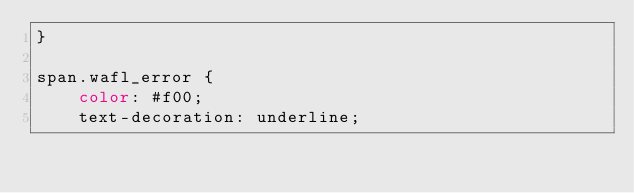<code> <loc_0><loc_0><loc_500><loc_500><_CSS_>}

span.wafl_error {
    color: #f00;
    text-decoration: underline;

</code> 